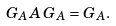<formula> <loc_0><loc_0><loc_500><loc_500>G _ { A } A \, G _ { A } = G _ { A } .</formula> 